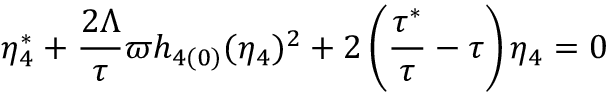Convert formula to latex. <formula><loc_0><loc_0><loc_500><loc_500>\eta _ { 4 } ^ { \ast } + \frac { 2 \Lambda } { \tau } \varpi h _ { 4 ( 0 ) } ( \eta _ { 4 } ) ^ { 2 } + 2 \left ( \frac { \tau ^ { \ast } } { \tau } - \tau \right ) \eta _ { 4 } = 0</formula> 